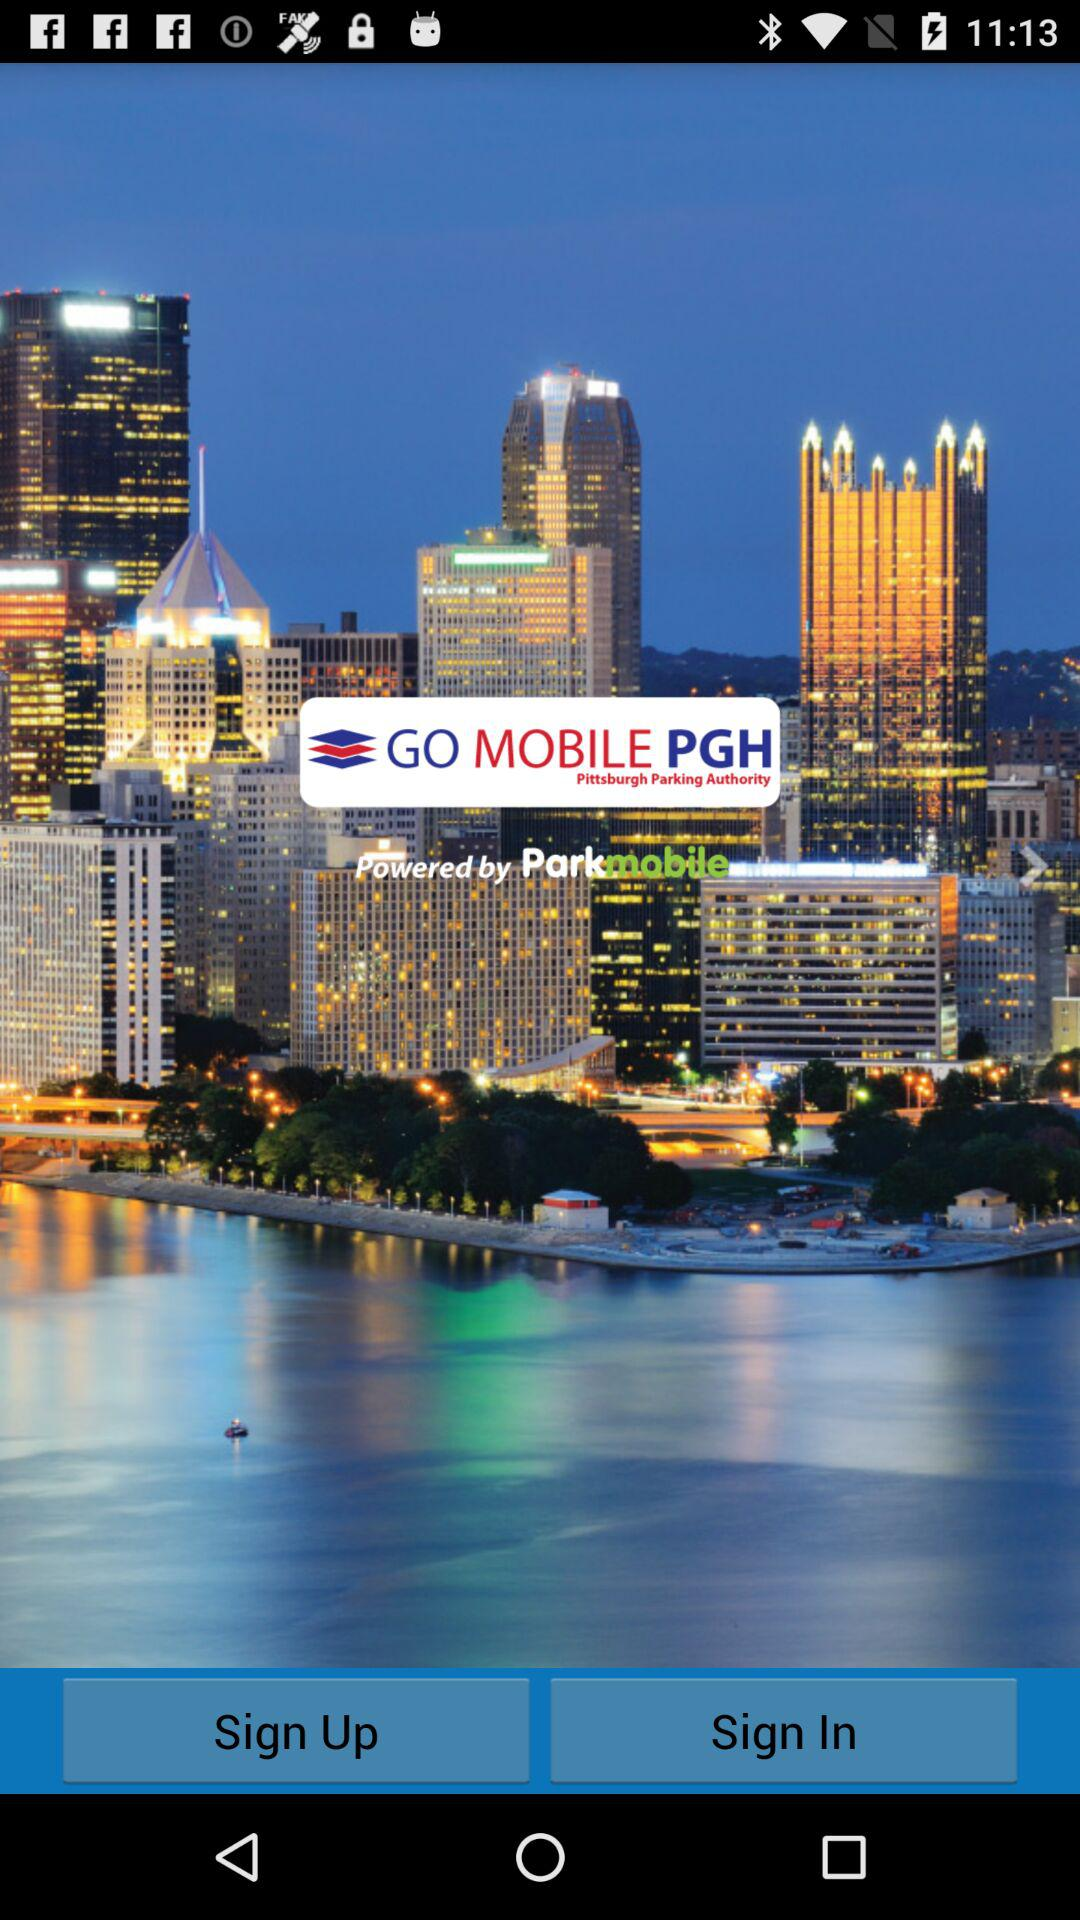By what company is the application powered? The application is powered by "Parkmobile". 